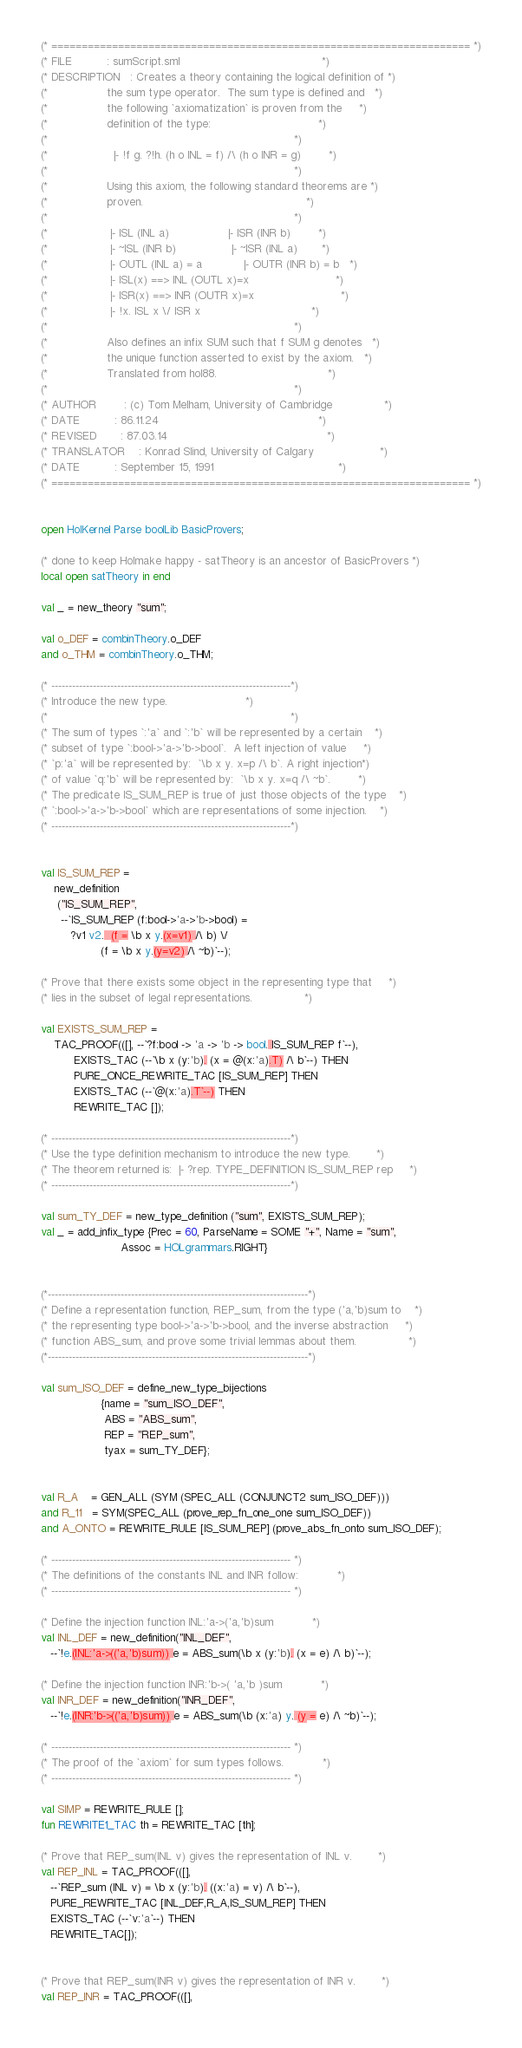Convert code to text. <code><loc_0><loc_0><loc_500><loc_500><_SML_>(* ===================================================================== *)
(* FILE          : sumScript.sml                                         *)
(* DESCRIPTION   : Creates a theory containing the logical definition of *)
(*                 the sum type operator.  The sum type is defined and   *)
(*                 the following `axiomatization` is proven from the     *)
(*                 definition of the type:                               *)
(*                                                                       *)
(*                   |- !f g. ?!h. (h o INL = f) /\ (h o INR = g)        *)
(*                                                                       *)
(*                 Using this axiom, the following standard theorems are *)
(*                 proven.                                               *)
(*                                                                       *)
(*                  |- ISL (INL a)                 |- ISR (INR b)        *)
(*                  |- ~ISL (INR b)                |- ~ISR (INL a)       *)
(*                  |- OUTL (INL a) = a            |- OUTR (INR b) = b   *)
(*                  |- ISL(x) ==> INL (OUTL x)=x                         *)
(*                  |- ISR(x) ==> INR (OUTR x)=x                         *)
(*                  |- !x. ISL x \/ ISR x                                *)
(*                                                                       *)
(*                 Also defines an infix SUM such that f SUM g denotes   *)
(*                 the unique function asserted to exist by the axiom.   *)
(*                 Translated from hol88.                                *)
(*                                                                       *)
(* AUTHOR        : (c) Tom Melham, University of Cambridge               *)
(* DATE          : 86.11.24                                              *)
(* REVISED       : 87.03.14                                              *)
(* TRANSLATOR    : Konrad Slind, University of Calgary                   *)
(* DATE          : September 15, 1991                                    *)
(* ===================================================================== *)


open HolKernel Parse boolLib BasicProvers;

(* done to keep Holmake happy - satTheory is an ancestor of BasicProvers *)
local open satTheory in end

val _ = new_theory "sum";

val o_DEF = combinTheory.o_DEF
and o_THM = combinTheory.o_THM;

(* ---------------------------------------------------------------------*)
(* Introduce the new type.						*)
(*                                                                      *)
(* The sum of types `:'a` and `:'b` will be represented by a certain	*)
(* subset of type `:bool->'a->'b->bool`.  A left injection of value     *)
(* `p:'a` will be represented by:  `\b x y. x=p /\ b`. A right injection*)
(* of value `q:'b` will be represented by:  `\b x y. x=q /\ ~b`.        *)
(* The predicate IS_SUM_REP is true of just those objects of the type	*)
(* `:bool->'a->'b->bool` which are representations of some injection.	*)
(* ---------------------------------------------------------------------*)


val IS_SUM_REP =
    new_definition
     ("IS_SUM_REP",
      --`IS_SUM_REP (f:bool->'a->'b->bool) =
         ?v1 v2.  (f = \b x y.(x=v1) /\ b) \/
                  (f = \b x y.(y=v2) /\ ~b)`--);

(* Prove that there exists some object in the representing type that 	*)
(* lies in the subset of legal representations.				*)

val EXISTS_SUM_REP =
    TAC_PROOF(([], --`?f:bool -> 'a -> 'b -> bool. IS_SUM_REP f`--),
	      EXISTS_TAC (--`\b x (y:'b). (x = @(x:'a).T) /\ b`--) THEN
	      PURE_ONCE_REWRITE_TAC [IS_SUM_REP] THEN
	      EXISTS_TAC (--`@(x:'a).T`--) THEN
	      REWRITE_TAC []);

(* ---------------------------------------------------------------------*)
(* Use the type definition mechanism to introduce the new type.		*)
(* The theorem returned is:  |- ?rep. TYPE_DEFINITION IS_SUM_REP rep 	*)
(* ---------------------------------------------------------------------*)

val sum_TY_DEF = new_type_definition ("sum", EXISTS_SUM_REP);
val _ = add_infix_type {Prec = 60, ParseName = SOME "+", Name = "sum",
                        Assoc = HOLgrammars.RIGHT}


(*---------------------------------------------------------------------------*)
(* Define a representation function, REP_sum, from the type ('a,'b)sum to    *)
(* the representing type bool->'a->'b->bool, and the inverse abstraction     *)
(* function ABS_sum, and prove some trivial lemmas about them.               *)
(*---------------------------------------------------------------------------*)

val sum_ISO_DEF = define_new_type_bijections
                  {name = "sum_ISO_DEF",
                   ABS = "ABS_sum",
                   REP = "REP_sum",
                   tyax = sum_TY_DEF};


val R_A    = GEN_ALL (SYM (SPEC_ALL (CONJUNCT2 sum_ISO_DEF)))
and R_11   = SYM(SPEC_ALL (prove_rep_fn_one_one sum_ISO_DEF))
and A_ONTO = REWRITE_RULE [IS_SUM_REP] (prove_abs_fn_onto sum_ISO_DEF);

(* --------------------------------------------------------------------- *)
(* The definitions of the constants INL and INR follow:			*)
(* --------------------------------------------------------------------- *)

(* Define the injection function INL:'a->('a,'b)sum			*)
val INL_DEF = new_definition("INL_DEF",
   --`!e.(INL:'a->(('a,'b)sum)) e = ABS_sum(\b x (y:'b). (x = e) /\ b)`--);

(* Define the injection function INR:'b->( 'a,'b )sum			*)
val INR_DEF = new_definition("INR_DEF",
   --`!e.(INR:'b->(('a,'b)sum)) e = ABS_sum(\b (x:'a) y. (y = e) /\ ~b)`--);

(* --------------------------------------------------------------------- *)
(* The proof of the `axiom` for sum types follows.			*)
(* --------------------------------------------------------------------- *)

val SIMP = REWRITE_RULE [];
fun REWRITE1_TAC th = REWRITE_TAC [th];

(* Prove that REP_sum(INL v) gives the representation of INL v.		*)
val REP_INL = TAC_PROOF(([],
   --`REP_sum (INL v) = \b x (y:'b). ((x:'a) = v) /\ b`--),
   PURE_REWRITE_TAC [INL_DEF,R_A,IS_SUM_REP] THEN
   EXISTS_TAC (--`v:'a`--) THEN
   REWRITE_TAC[]);


(* Prove that REP_sum(INR v) gives the representation of INR v.		*)
val REP_INR = TAC_PROOF(([],</code> 